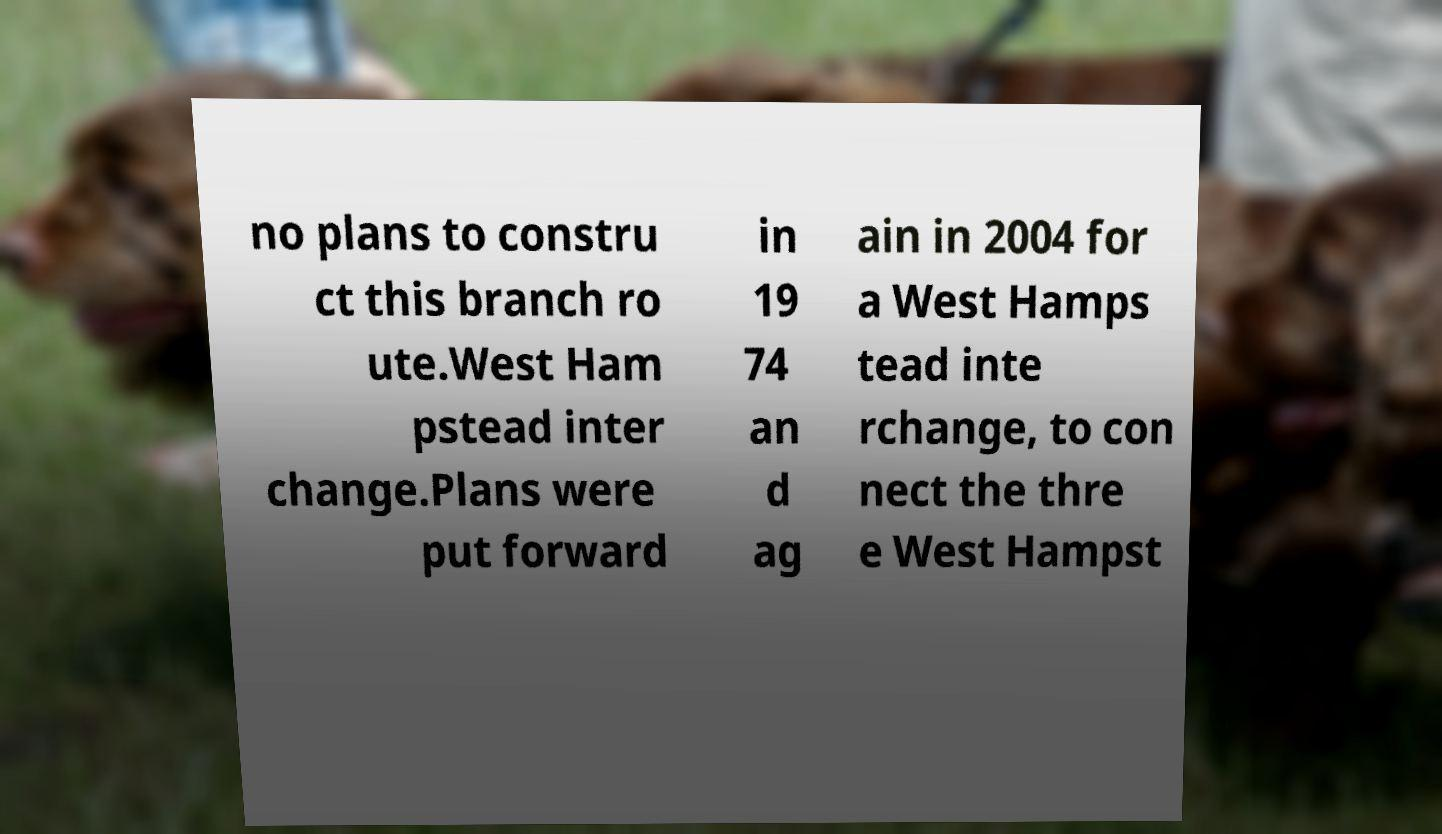Could you extract and type out the text from this image? no plans to constru ct this branch ro ute.West Ham pstead inter change.Plans were put forward in 19 74 an d ag ain in 2004 for a West Hamps tead inte rchange, to con nect the thre e West Hampst 